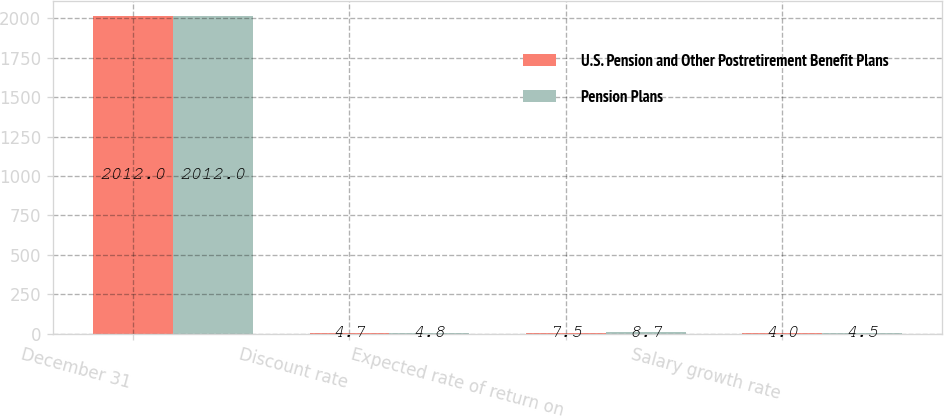Convert chart. <chart><loc_0><loc_0><loc_500><loc_500><stacked_bar_chart><ecel><fcel>December 31<fcel>Discount rate<fcel>Expected rate of return on<fcel>Salary growth rate<nl><fcel>U.S. Pension and Other Postretirement Benefit Plans<fcel>2012<fcel>4.7<fcel>7.5<fcel>4<nl><fcel>Pension Plans<fcel>2012<fcel>4.8<fcel>8.7<fcel>4.5<nl></chart> 